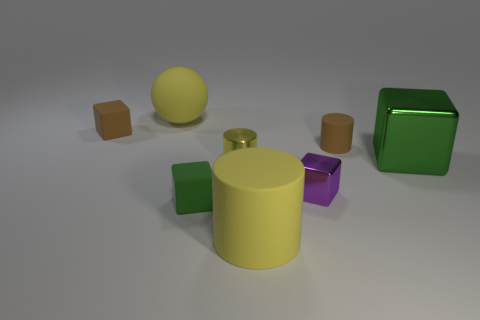Is there any other thing that is the same shape as the yellow shiny object?
Your answer should be compact. Yes. Are there any green matte cubes that are in front of the large yellow rubber cylinder to the right of the tiny green cube?
Your answer should be compact. No. What is the color of the other big object that is the same shape as the green rubber thing?
Provide a short and direct response. Green. What number of large metal cubes are the same color as the large metal thing?
Your answer should be very brief. 0. The cylinder to the left of the large matte object in front of the tiny matte cube that is in front of the brown matte cylinder is what color?
Offer a very short reply. Yellow. Do the large block and the small brown cylinder have the same material?
Your answer should be very brief. No. Is the purple metallic thing the same shape as the small green rubber thing?
Your response must be concise. Yes. Is the number of small cubes that are behind the tiny shiny cube the same as the number of big metallic blocks that are right of the small yellow object?
Keep it short and to the point. Yes. There is a big thing that is made of the same material as the tiny yellow cylinder; what is its color?
Offer a terse response. Green. How many green blocks are made of the same material as the small yellow cylinder?
Provide a succinct answer. 1. 